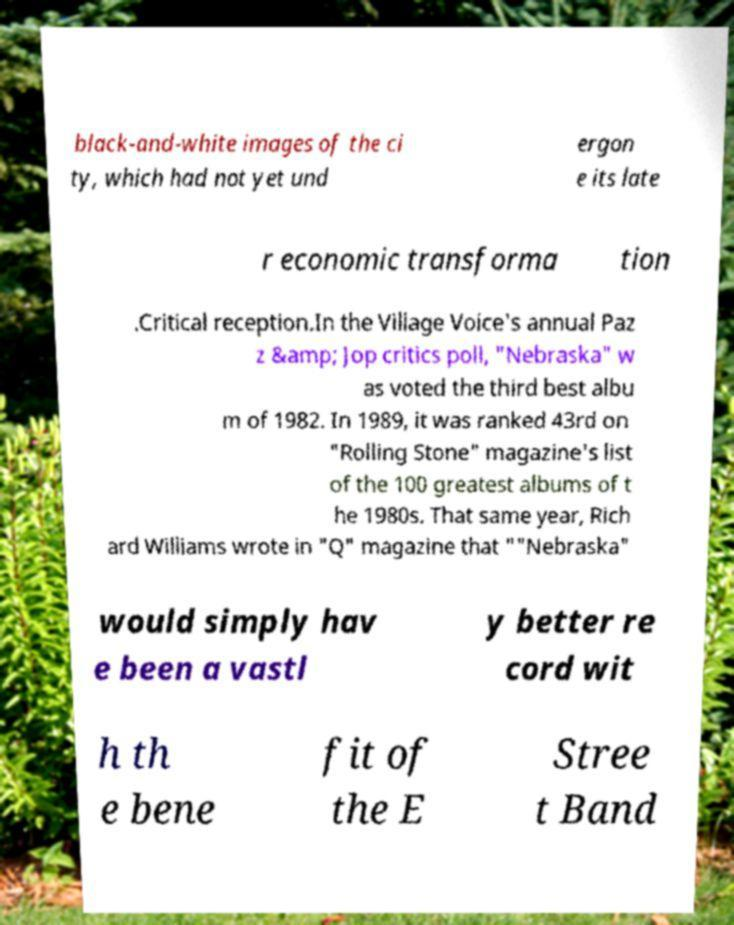What messages or text are displayed in this image? I need them in a readable, typed format. black-and-white images of the ci ty, which had not yet und ergon e its late r economic transforma tion .Critical reception.In the Village Voice's annual Paz z &amp; Jop critics poll, "Nebraska" w as voted the third best albu m of 1982. In 1989, it was ranked 43rd on "Rolling Stone" magazine's list of the 100 greatest albums of t he 1980s. That same year, Rich ard Williams wrote in "Q" magazine that ""Nebraska" would simply hav e been a vastl y better re cord wit h th e bene fit of the E Stree t Band 